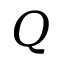Convert formula to latex. <formula><loc_0><loc_0><loc_500><loc_500>Q</formula> 